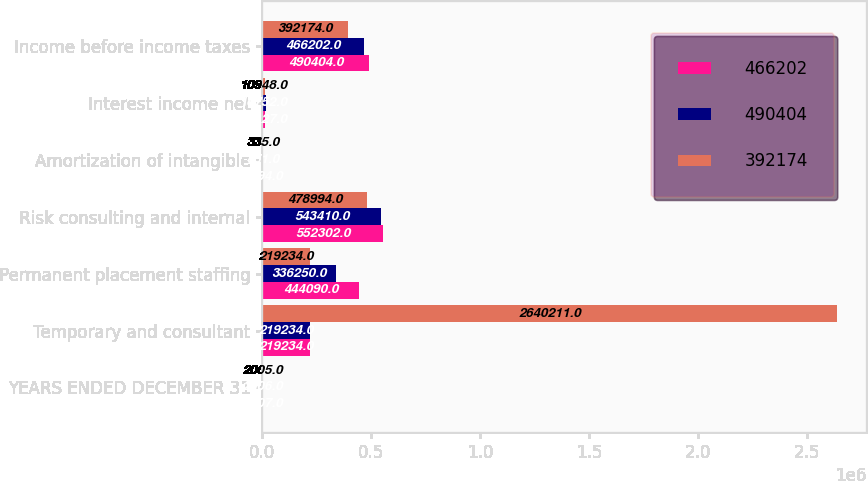Convert chart to OTSL. <chart><loc_0><loc_0><loc_500><loc_500><stacked_bar_chart><ecel><fcel>YEARS ENDED DECEMBER 31<fcel>Temporary and consultant<fcel>Permanent placement staffing<fcel>Risk consulting and internal<fcel>Amortization of intangible<fcel>Interest income net<fcel>Income before income taxes<nl><fcel>466202<fcel>2007<fcel>219234<fcel>444090<fcel>552302<fcel>2594<fcel>13127<fcel>490404<nl><fcel>490404<fcel>2006<fcel>219234<fcel>336250<fcel>543410<fcel>851<fcel>16752<fcel>466202<nl><fcel>392174<fcel>2005<fcel>2.64021e+06<fcel>219234<fcel>478994<fcel>335<fcel>10948<fcel>392174<nl></chart> 